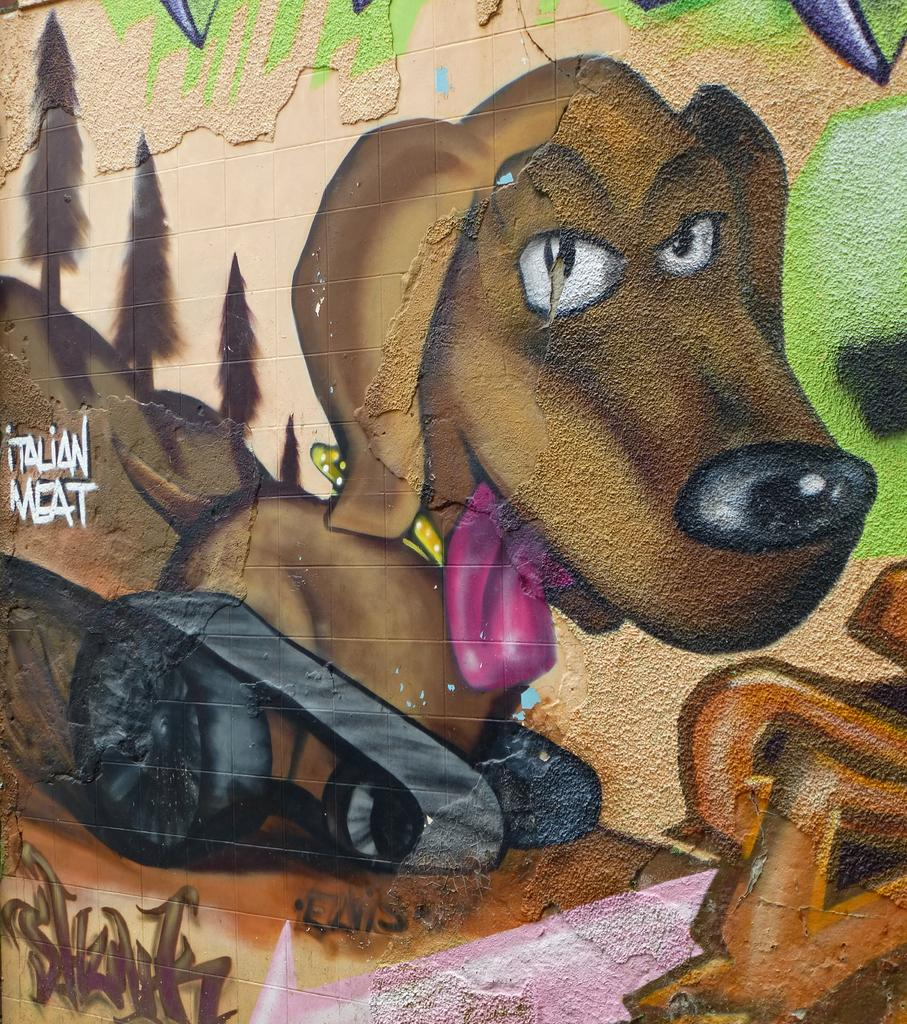What is present on the wall in the image? There is graffiti on the wall in the image. What color is the graffiti? The graffiti is written in white color. How many pies are displayed on the wall in the image? There are no pies present in the image; it features graffiti on the wall. What type of zipper can be seen on the wall in the image? There is no zipper present on the wall in the image. 